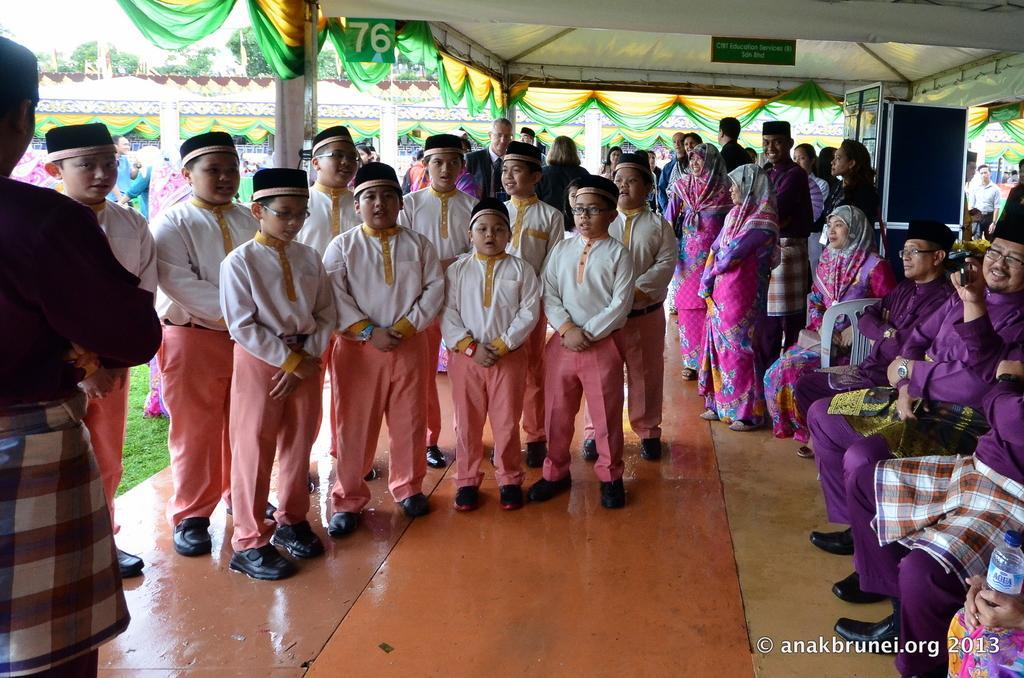Describe this image in one or two sentences. In this image there are few kids standing on the floor. On the right side there are few persons who are sitting in the chairs while the other people are standing on the floor. At the bottom there is a number board. On the right side top there is a speaker. At the top there is ceiling. In the background there are few other people standing on the ground. There is a cloth which is arranged around the pillars. 